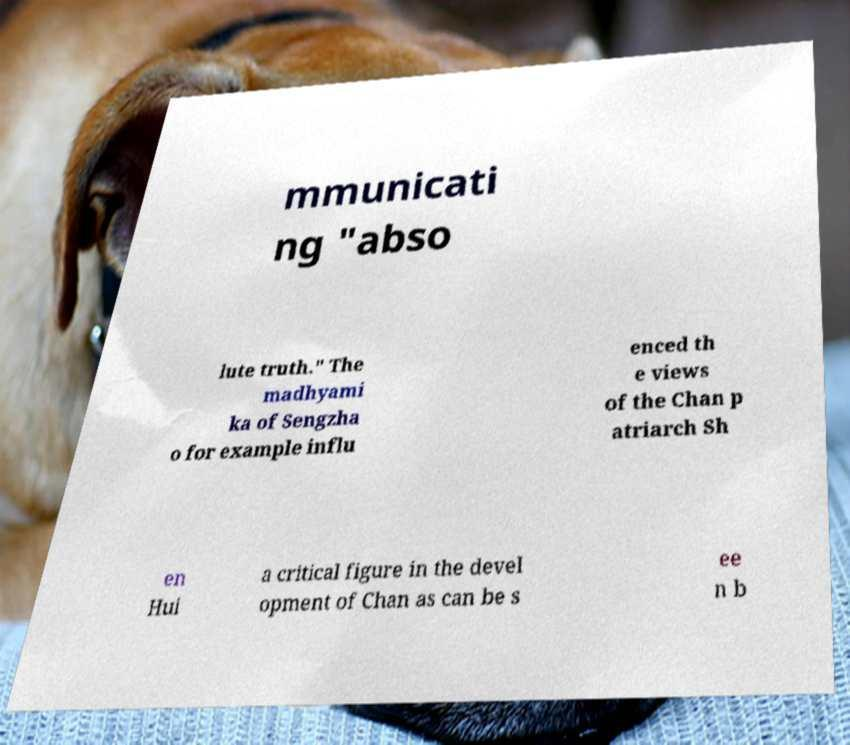Please read and relay the text visible in this image. What does it say? mmunicati ng "abso lute truth." The madhyami ka of Sengzha o for example influ enced th e views of the Chan p atriarch Sh en Hui a critical figure in the devel opment of Chan as can be s ee n b 